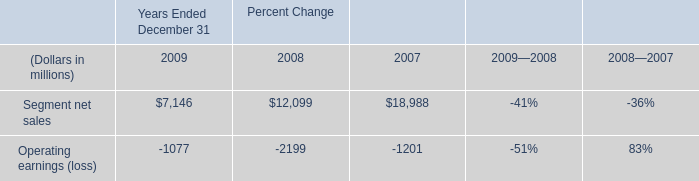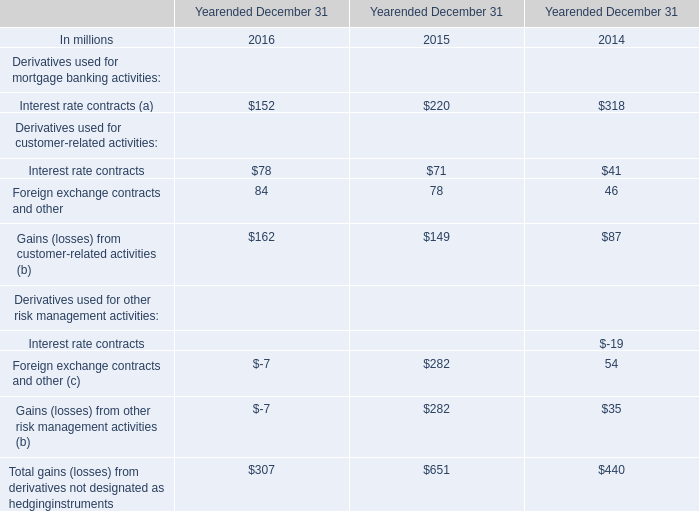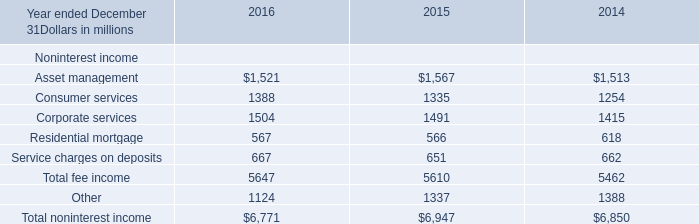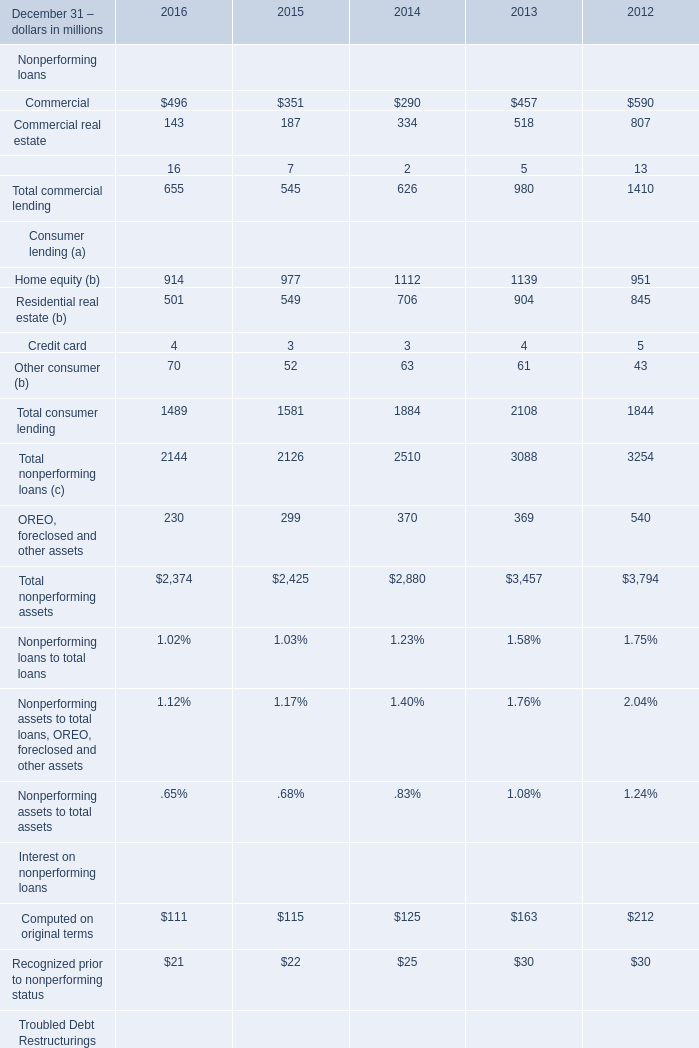What is the growing rate of Corporate services in the year with the most Service charges on deposits? 
Computations: ((1504 - 1491) / 1491)
Answer: 0.00872. 